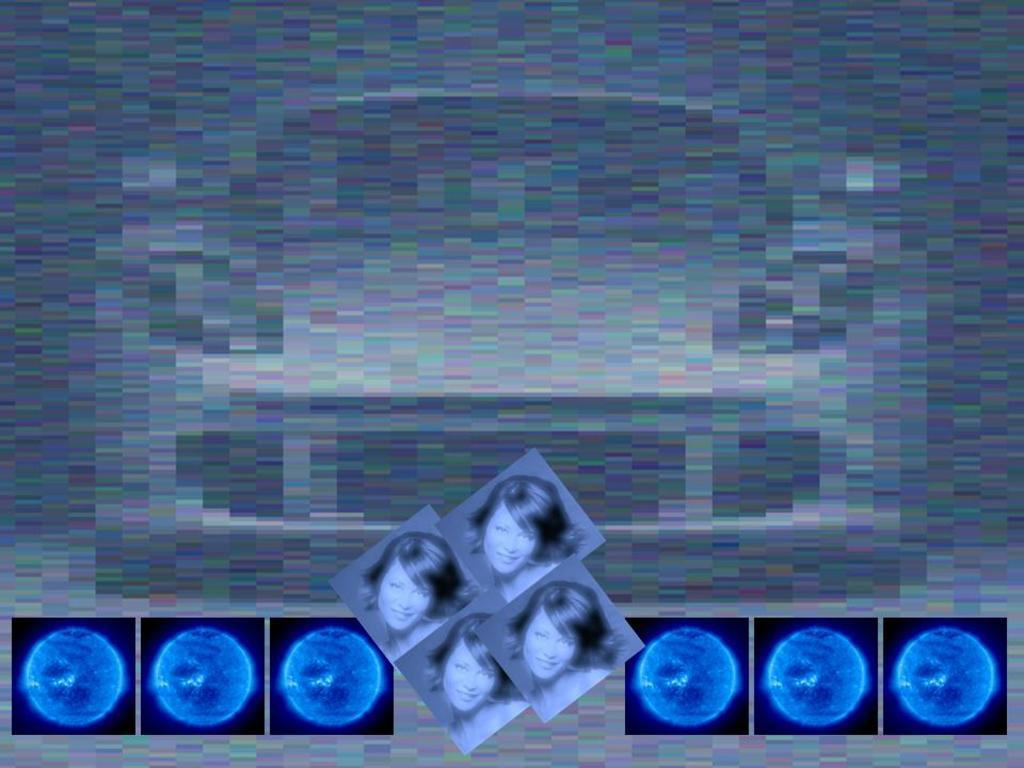What is being depicted in the image? There are depiction pictures of a woman and blue color things in the image. Can you describe the quality of the image? The image is slightly blurry. What type of stew is being prepared in the image? There is no stew present in the image; it features depiction pictures of a woman and blue color things. What angle is the insect shown from in the image? There is no insect present in the image. 